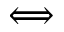Convert formula to latex. <formula><loc_0><loc_0><loc_500><loc_500>\Longleftrightarrow</formula> 